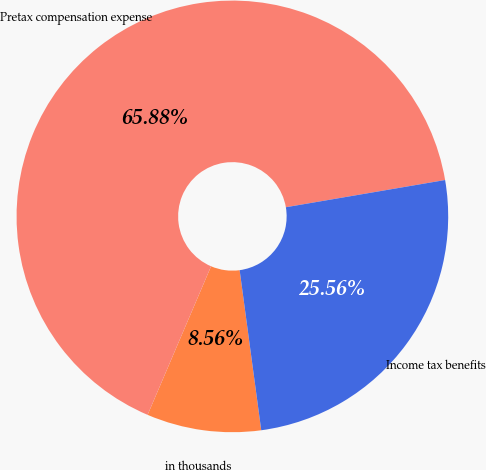Convert chart. <chart><loc_0><loc_0><loc_500><loc_500><pie_chart><fcel>in thousands<fcel>Pretax compensation expense<fcel>Income tax benefits<nl><fcel>8.56%<fcel>65.88%<fcel>25.56%<nl></chart> 